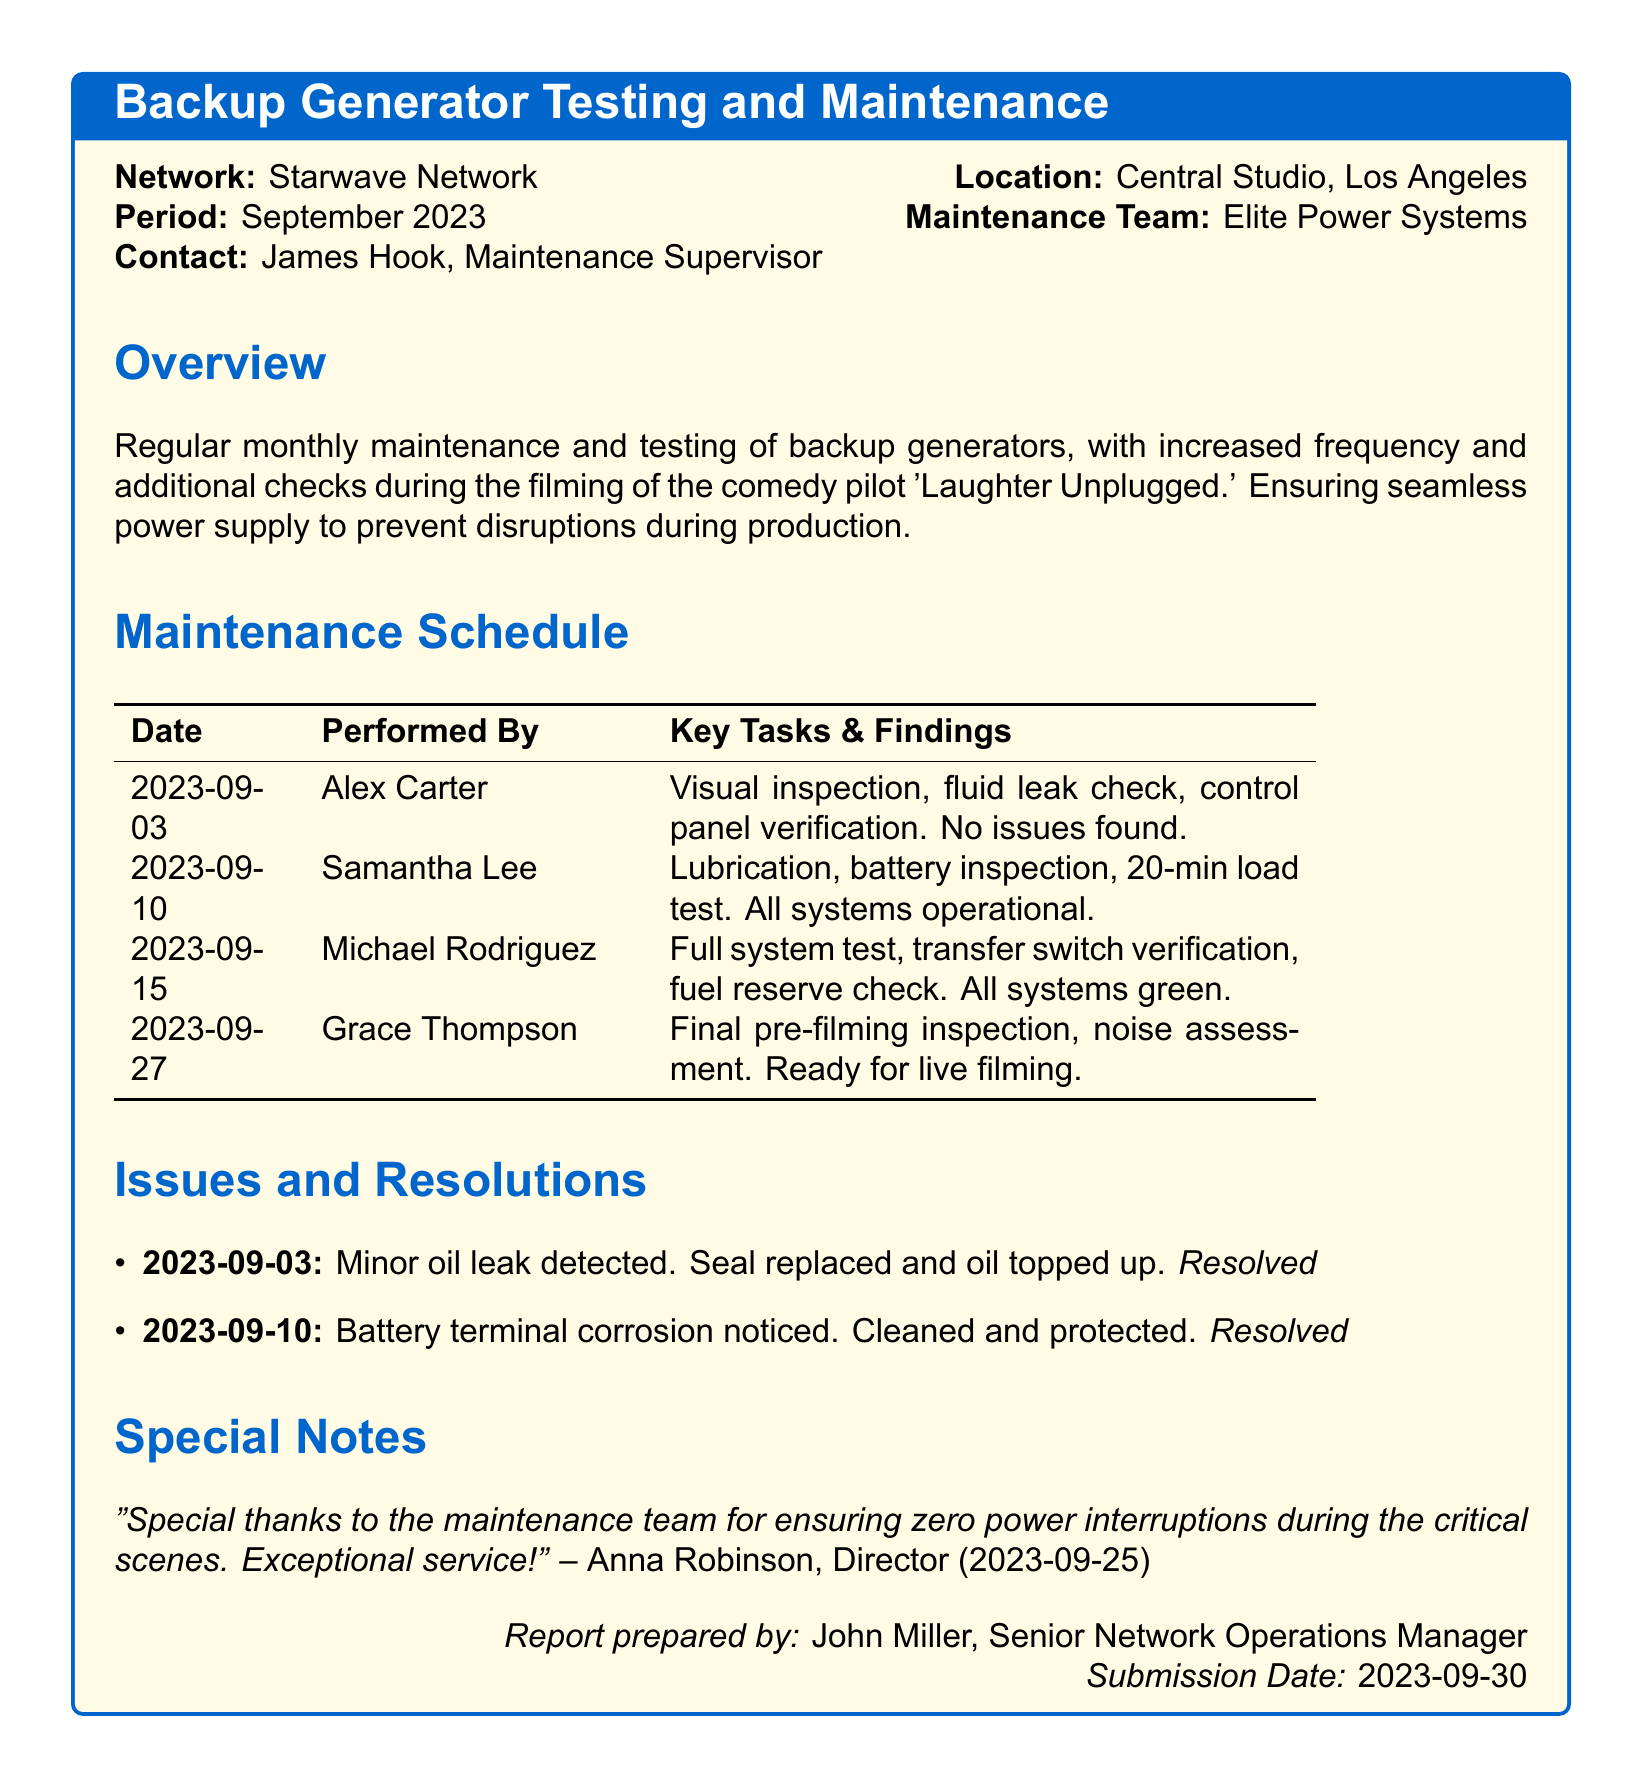What is the name of the network? The network name is explicitly stated at the beginning of the document.
Answer: Starwave Network Who is the maintenance supervisor? The maintenance supervisor's name is provided in the contact details.
Answer: James Hook What date was the final pre-filming inspection performed? This date is listed in the maintenance schedule under key tasks.
Answer: 2023-09-27 How many key tasks were performed on September 10? The maintenance schedule specifies the tasks for that date.
Answer: 3 What issue was resolved on September 3? The specific issue addressed on that date is mentioned in the issues section.
Answer: Minor oil leak What was the outcome of the battery inspection on September 10? The document provides a note about the result of the inspection performed on that date.
Answer: All systems operational What is the main purpose of the maintenance log? The overview section describes the purpose of the log.
Answer: Prevent disruptions during production How many members were on the maintenance team? The document does not explicitly state the number of members, but only lists tasks by different individuals.
Answer: 4 